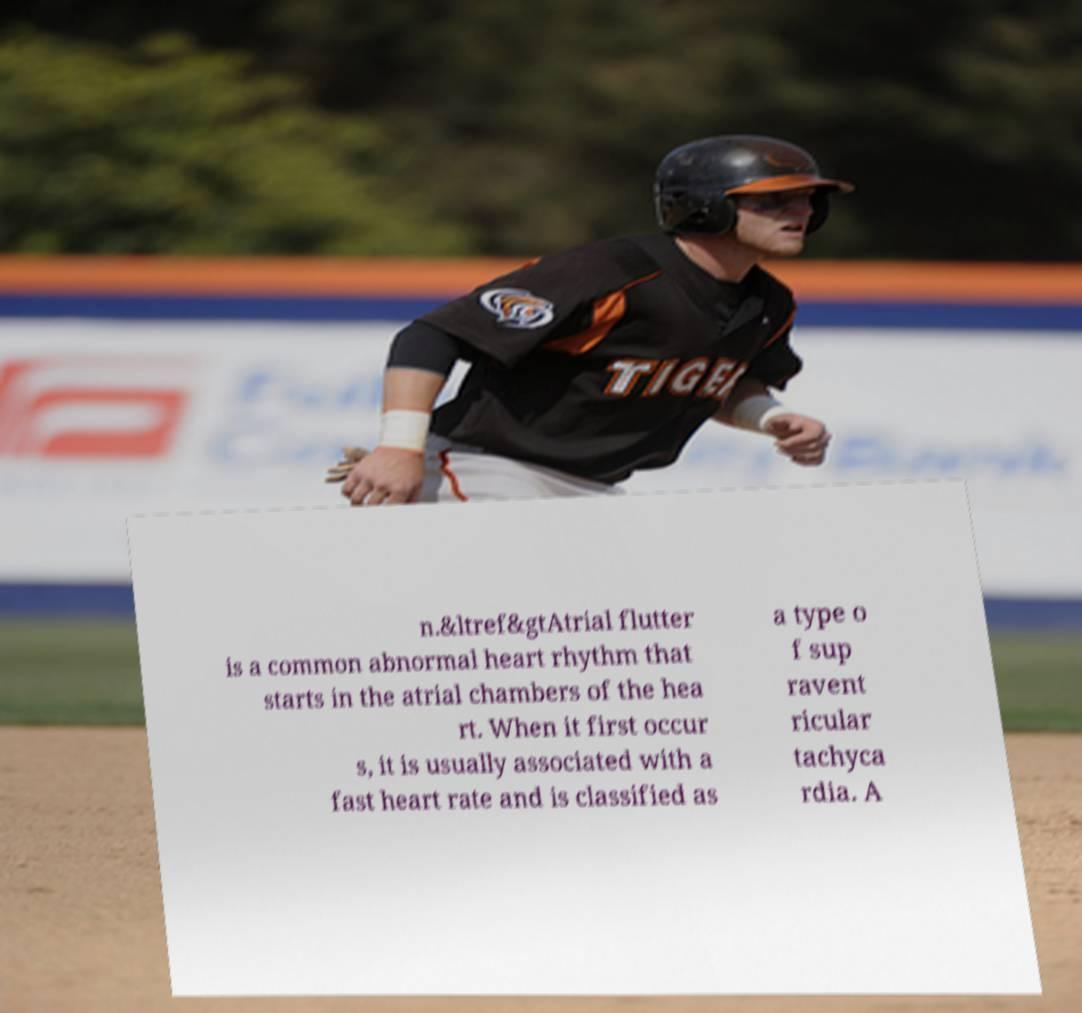For documentation purposes, I need the text within this image transcribed. Could you provide that? n.&ltref&gtAtrial flutter is a common abnormal heart rhythm that starts in the atrial chambers of the hea rt. When it first occur s, it is usually associated with a fast heart rate and is classified as a type o f sup ravent ricular tachyca rdia. A 